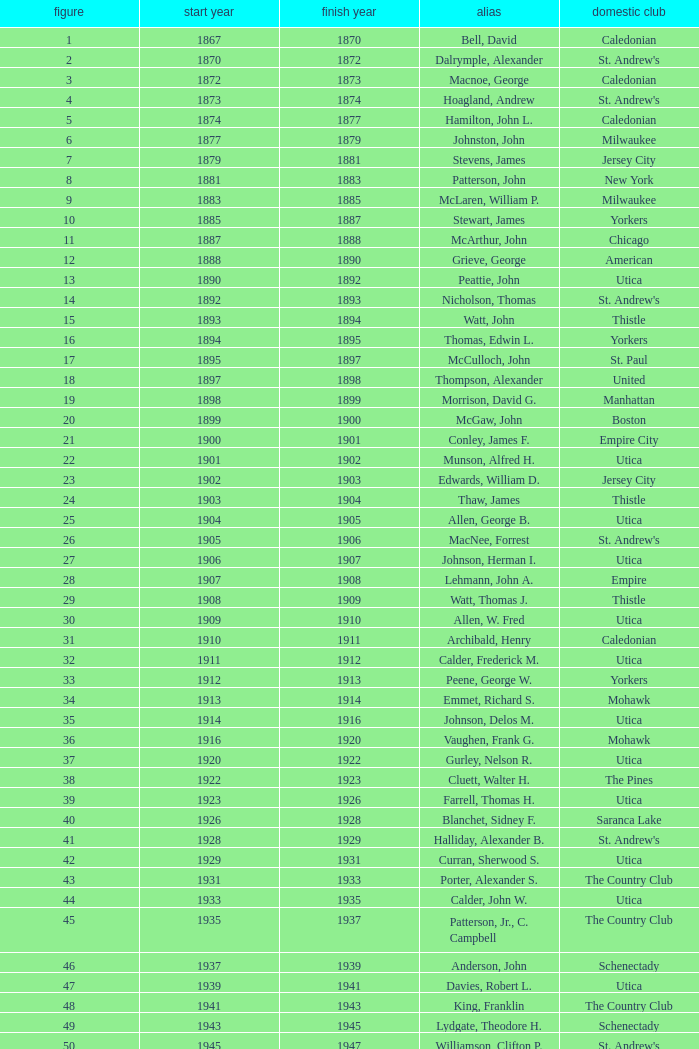Which Number has a Name of hill, lucius t.? 53.0. 